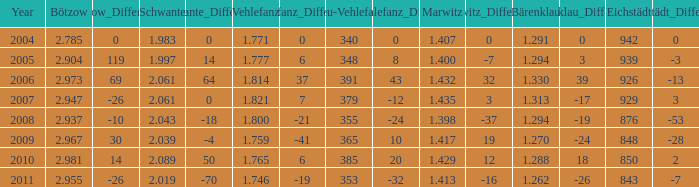What year has a Schwante smaller than 2.043, an Eichstädt smaller than 848, and a Bärenklau smaller than 1.262? 0.0. 